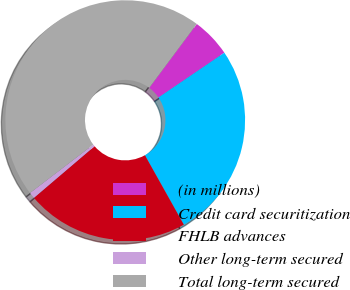Convert chart to OTSL. <chart><loc_0><loc_0><loc_500><loc_500><pie_chart><fcel>(in millions)<fcel>Credit card securitization<fcel>FHLB advances<fcel>Other long-term secured<fcel>Total long-term secured<nl><fcel>5.31%<fcel>26.37%<fcel>21.9%<fcel>0.84%<fcel>45.57%<nl></chart> 